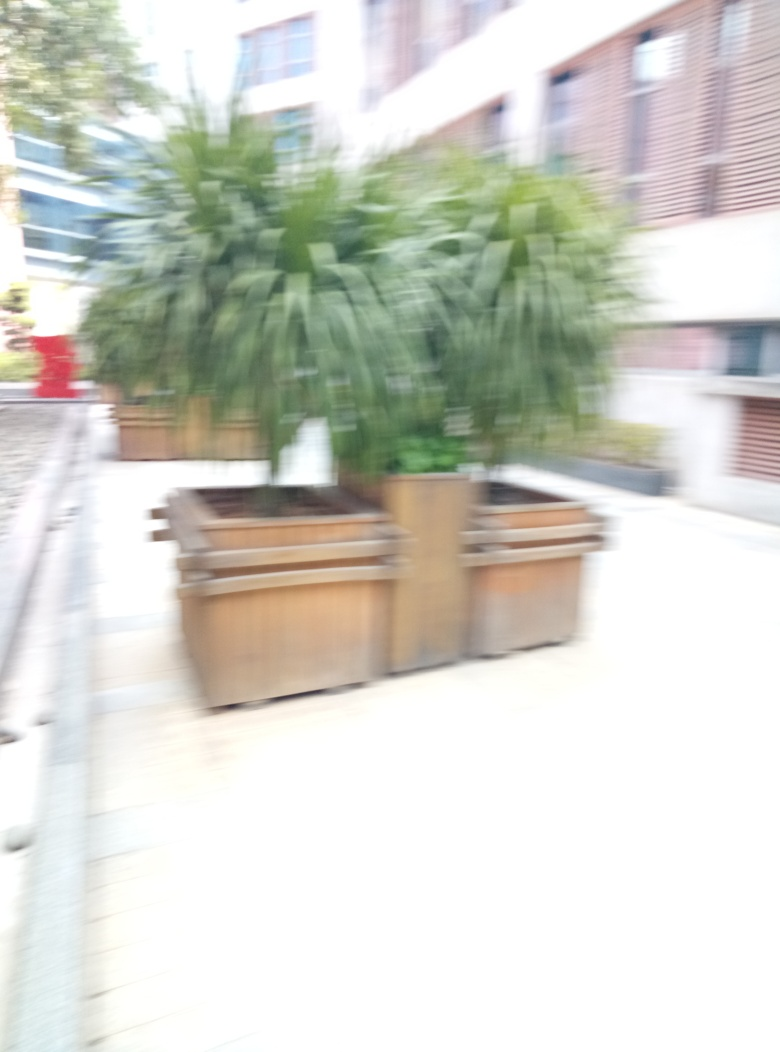Can you tell what kind of plants are in the pot despite the blur? It's challenging to identify the specific species due to the blur, but the plants appear to be lush and leafy, with no discernible flowers. They might be common foliage plants used for outdoor decoration. 